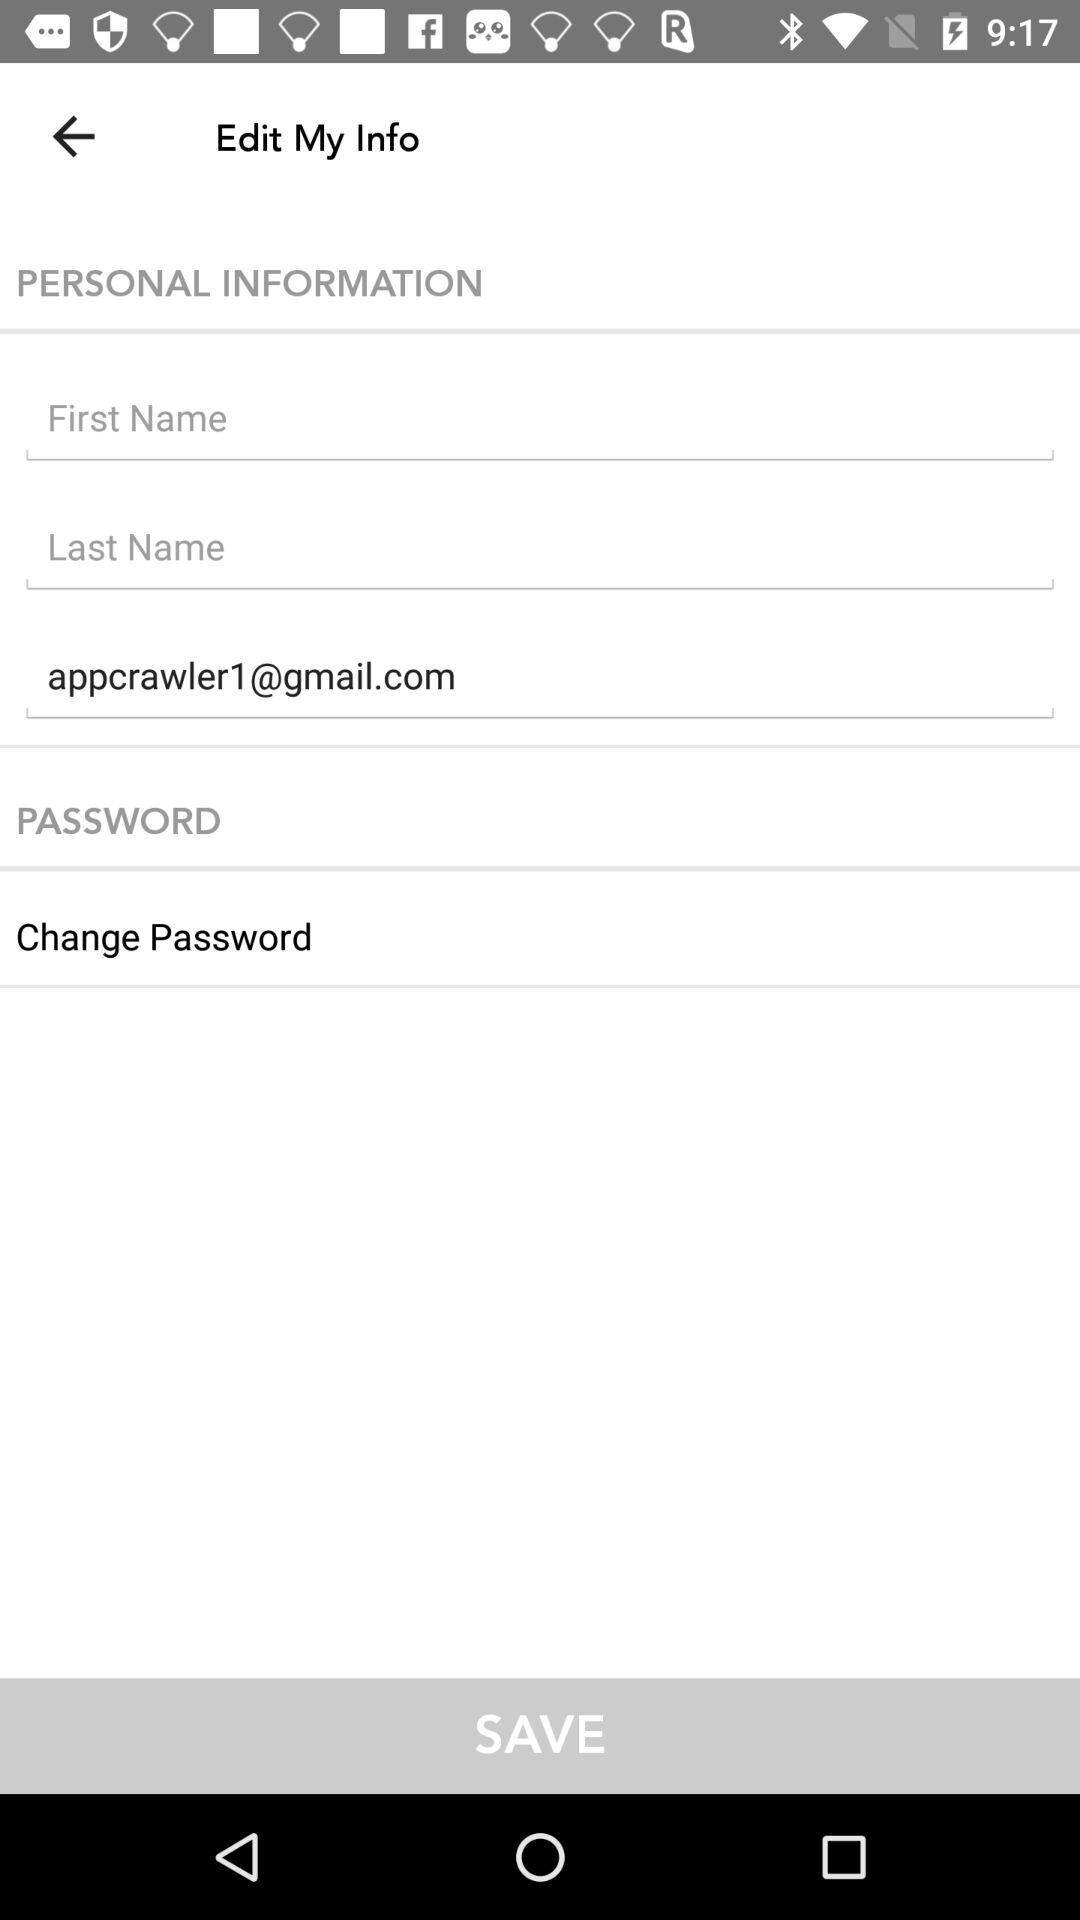What is the email address of the user? The email address of the user is appcrawler1@gmail.com. 